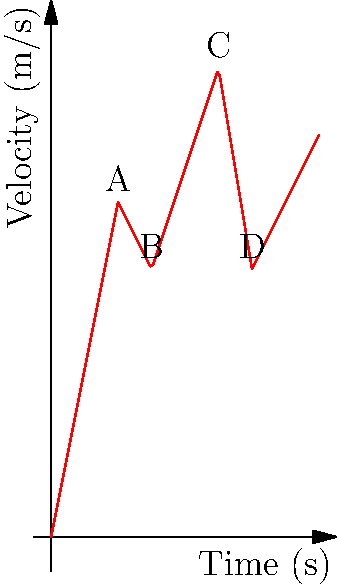Analyze the velocity-time graph of a running back performing a zigzag run. The graph shows four distinct phases (A, B, C, and D) of acceleration and deceleration. Calculate the total displacement of the running back during this 8-second run. To find the total displacement, we need to calculate the area under the velocity-time curve. We can break this down into several steps:

1) First 2 seconds (0-2s): Uniform acceleration
   Area = $\frac{1}{2} \times 2 \times 10 = 10$ m

2) From 2s to 3s (phase A to B): Deceleration
   Area = $\frac{1}{2} \times (10 + 8) \times 1 = 9$ m

3) From 3s to 5s (phase B to C): Acceleration
   Area = $8 \times 2 + \frac{1}{2} \times 2 \times 6 = 22$ m

4) From 5s to 6s (phase C to D): Rapid deceleration
   Area = $\frac{1}{2} \times (14 + 8) \times 1 = 11$ m

5) Final 2 seconds (6-8s): Uniform acceleration
   Area = $8 \times 2 + \frac{1}{2} \times 2 \times 4 = 20$ m

Total displacement = Sum of all areas
$10 + 9 + 22 + 11 + 20 = 72$ m

Therefore, the total displacement of the running back during this 8-second zigzag run is 72 meters.
Answer: 72 meters 